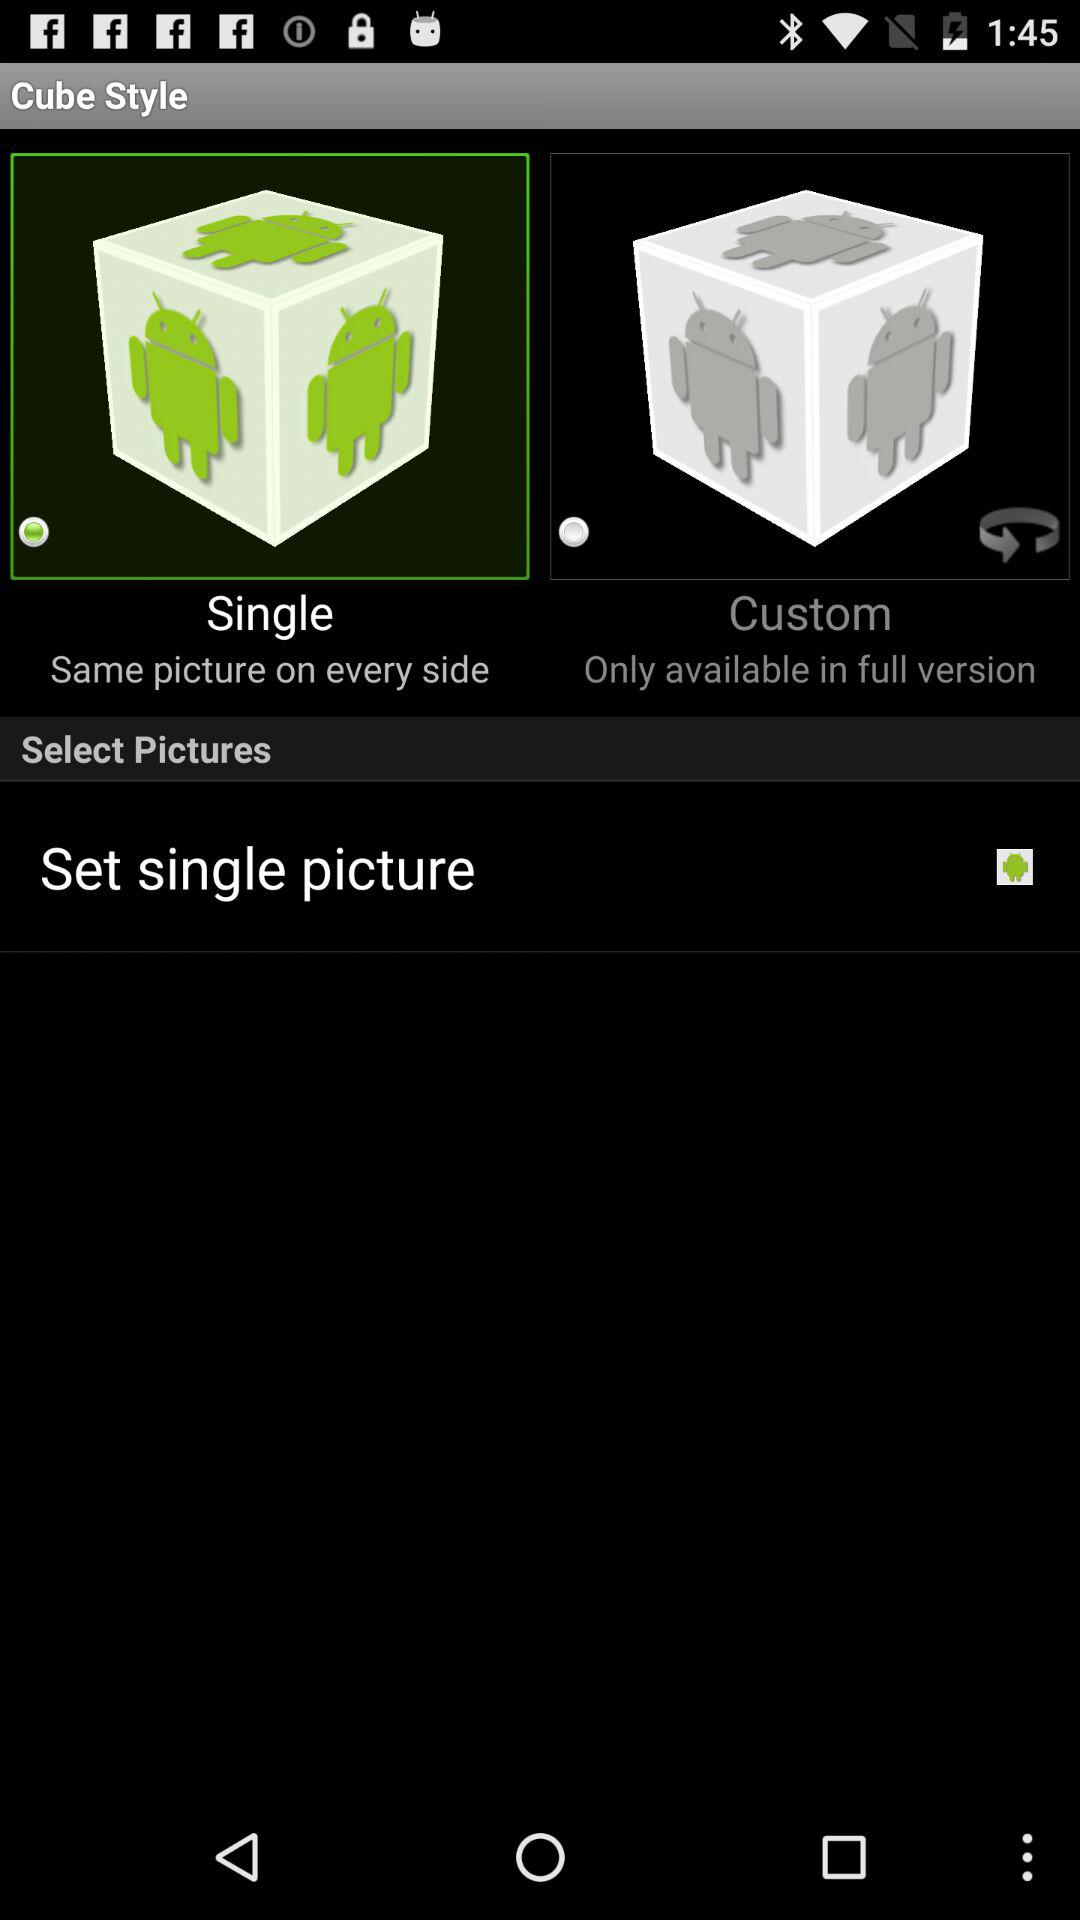Which cube style was selected? The selected cube style was "Single". 